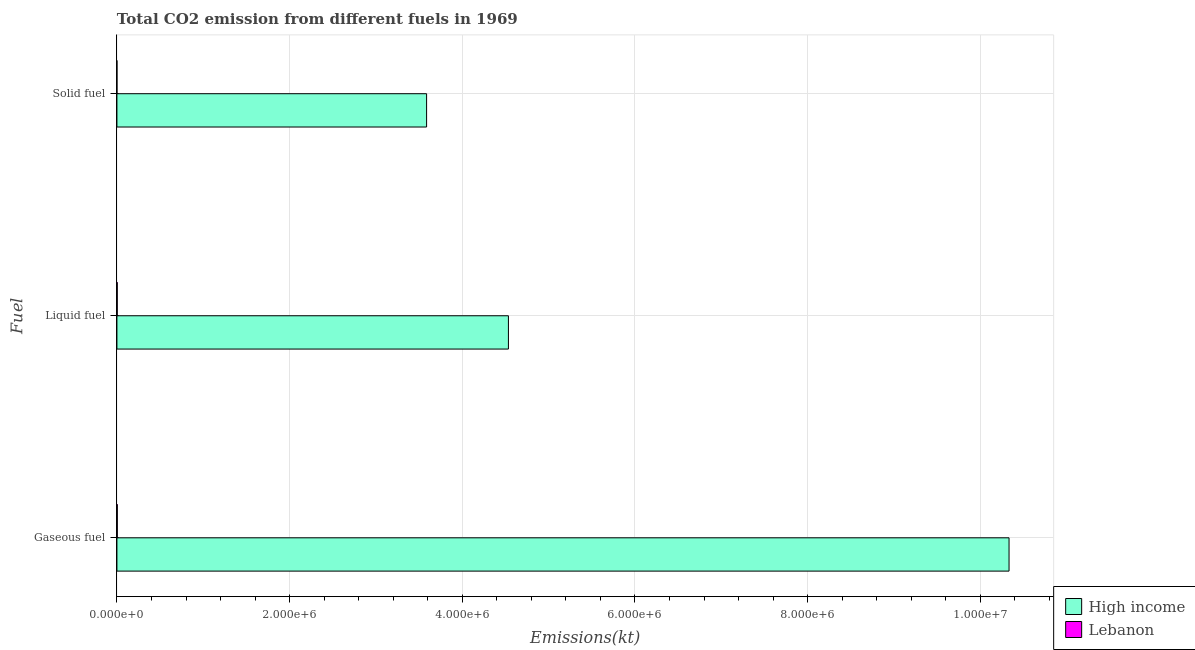How many different coloured bars are there?
Your answer should be compact. 2. How many groups of bars are there?
Your answer should be compact. 3. Are the number of bars per tick equal to the number of legend labels?
Ensure brevity in your answer.  Yes. How many bars are there on the 2nd tick from the top?
Your response must be concise. 2. How many bars are there on the 2nd tick from the bottom?
Make the answer very short. 2. What is the label of the 2nd group of bars from the top?
Offer a very short reply. Liquid fuel. What is the amount of co2 emissions from gaseous fuel in High income?
Offer a terse response. 1.03e+07. Across all countries, what is the maximum amount of co2 emissions from gaseous fuel?
Give a very brief answer. 1.03e+07. Across all countries, what is the minimum amount of co2 emissions from solid fuel?
Make the answer very short. 25.67. In which country was the amount of co2 emissions from solid fuel minimum?
Keep it short and to the point. Lebanon. What is the total amount of co2 emissions from gaseous fuel in the graph?
Keep it short and to the point. 1.03e+07. What is the difference between the amount of co2 emissions from gaseous fuel in High income and that in Lebanon?
Offer a terse response. 1.03e+07. What is the difference between the amount of co2 emissions from liquid fuel in Lebanon and the amount of co2 emissions from gaseous fuel in High income?
Ensure brevity in your answer.  -1.03e+07. What is the average amount of co2 emissions from gaseous fuel per country?
Give a very brief answer. 5.17e+06. What is the difference between the amount of co2 emissions from solid fuel and amount of co2 emissions from gaseous fuel in High income?
Ensure brevity in your answer.  -6.75e+06. What is the ratio of the amount of co2 emissions from gaseous fuel in High income to that in Lebanon?
Keep it short and to the point. 2373.84. Is the difference between the amount of co2 emissions from gaseous fuel in Lebanon and High income greater than the difference between the amount of co2 emissions from liquid fuel in Lebanon and High income?
Provide a short and direct response. No. What is the difference between the highest and the second highest amount of co2 emissions from solid fuel?
Ensure brevity in your answer.  3.59e+06. What is the difference between the highest and the lowest amount of co2 emissions from solid fuel?
Your response must be concise. 3.59e+06. What does the 1st bar from the top in Gaseous fuel represents?
Provide a short and direct response. Lebanon. What does the 2nd bar from the bottom in Solid fuel represents?
Your response must be concise. Lebanon. Is it the case that in every country, the sum of the amount of co2 emissions from gaseous fuel and amount of co2 emissions from liquid fuel is greater than the amount of co2 emissions from solid fuel?
Keep it short and to the point. Yes. Are all the bars in the graph horizontal?
Offer a terse response. Yes. What is the difference between two consecutive major ticks on the X-axis?
Ensure brevity in your answer.  2.00e+06. What is the title of the graph?
Ensure brevity in your answer.  Total CO2 emission from different fuels in 1969. What is the label or title of the X-axis?
Your response must be concise. Emissions(kt). What is the label or title of the Y-axis?
Offer a very short reply. Fuel. What is the Emissions(kt) of High income in Gaseous fuel?
Your answer should be very brief. 1.03e+07. What is the Emissions(kt) of Lebanon in Gaseous fuel?
Make the answer very short. 4352.73. What is the Emissions(kt) in High income in Liquid fuel?
Give a very brief answer. 4.53e+06. What is the Emissions(kt) of Lebanon in Liquid fuel?
Offer a very short reply. 3703.67. What is the Emissions(kt) of High income in Solid fuel?
Your answer should be very brief. 3.59e+06. What is the Emissions(kt) of Lebanon in Solid fuel?
Provide a succinct answer. 25.67. Across all Fuel, what is the maximum Emissions(kt) in High income?
Offer a terse response. 1.03e+07. Across all Fuel, what is the maximum Emissions(kt) in Lebanon?
Your answer should be compact. 4352.73. Across all Fuel, what is the minimum Emissions(kt) of High income?
Your response must be concise. 3.59e+06. Across all Fuel, what is the minimum Emissions(kt) of Lebanon?
Ensure brevity in your answer.  25.67. What is the total Emissions(kt) in High income in the graph?
Your answer should be compact. 1.85e+07. What is the total Emissions(kt) in Lebanon in the graph?
Offer a terse response. 8082.07. What is the difference between the Emissions(kt) of High income in Gaseous fuel and that in Liquid fuel?
Keep it short and to the point. 5.80e+06. What is the difference between the Emissions(kt) of Lebanon in Gaseous fuel and that in Liquid fuel?
Your response must be concise. 649.06. What is the difference between the Emissions(kt) in High income in Gaseous fuel and that in Solid fuel?
Your response must be concise. 6.75e+06. What is the difference between the Emissions(kt) of Lebanon in Gaseous fuel and that in Solid fuel?
Give a very brief answer. 4327.06. What is the difference between the Emissions(kt) in High income in Liquid fuel and that in Solid fuel?
Give a very brief answer. 9.48e+05. What is the difference between the Emissions(kt) of Lebanon in Liquid fuel and that in Solid fuel?
Offer a terse response. 3678. What is the difference between the Emissions(kt) in High income in Gaseous fuel and the Emissions(kt) in Lebanon in Liquid fuel?
Ensure brevity in your answer.  1.03e+07. What is the difference between the Emissions(kt) in High income in Gaseous fuel and the Emissions(kt) in Lebanon in Solid fuel?
Keep it short and to the point. 1.03e+07. What is the difference between the Emissions(kt) in High income in Liquid fuel and the Emissions(kt) in Lebanon in Solid fuel?
Provide a succinct answer. 4.53e+06. What is the average Emissions(kt) in High income per Fuel?
Your response must be concise. 6.15e+06. What is the average Emissions(kt) in Lebanon per Fuel?
Your answer should be very brief. 2694.02. What is the difference between the Emissions(kt) of High income and Emissions(kt) of Lebanon in Gaseous fuel?
Provide a short and direct response. 1.03e+07. What is the difference between the Emissions(kt) of High income and Emissions(kt) of Lebanon in Liquid fuel?
Give a very brief answer. 4.53e+06. What is the difference between the Emissions(kt) of High income and Emissions(kt) of Lebanon in Solid fuel?
Your response must be concise. 3.59e+06. What is the ratio of the Emissions(kt) in High income in Gaseous fuel to that in Liquid fuel?
Make the answer very short. 2.28. What is the ratio of the Emissions(kt) in Lebanon in Gaseous fuel to that in Liquid fuel?
Keep it short and to the point. 1.18. What is the ratio of the Emissions(kt) of High income in Gaseous fuel to that in Solid fuel?
Your answer should be compact. 2.88. What is the ratio of the Emissions(kt) in Lebanon in Gaseous fuel to that in Solid fuel?
Offer a terse response. 169.57. What is the ratio of the Emissions(kt) of High income in Liquid fuel to that in Solid fuel?
Provide a short and direct response. 1.26. What is the ratio of the Emissions(kt) in Lebanon in Liquid fuel to that in Solid fuel?
Your response must be concise. 144.29. What is the difference between the highest and the second highest Emissions(kt) of High income?
Your answer should be very brief. 5.80e+06. What is the difference between the highest and the second highest Emissions(kt) in Lebanon?
Keep it short and to the point. 649.06. What is the difference between the highest and the lowest Emissions(kt) in High income?
Provide a short and direct response. 6.75e+06. What is the difference between the highest and the lowest Emissions(kt) of Lebanon?
Provide a short and direct response. 4327.06. 